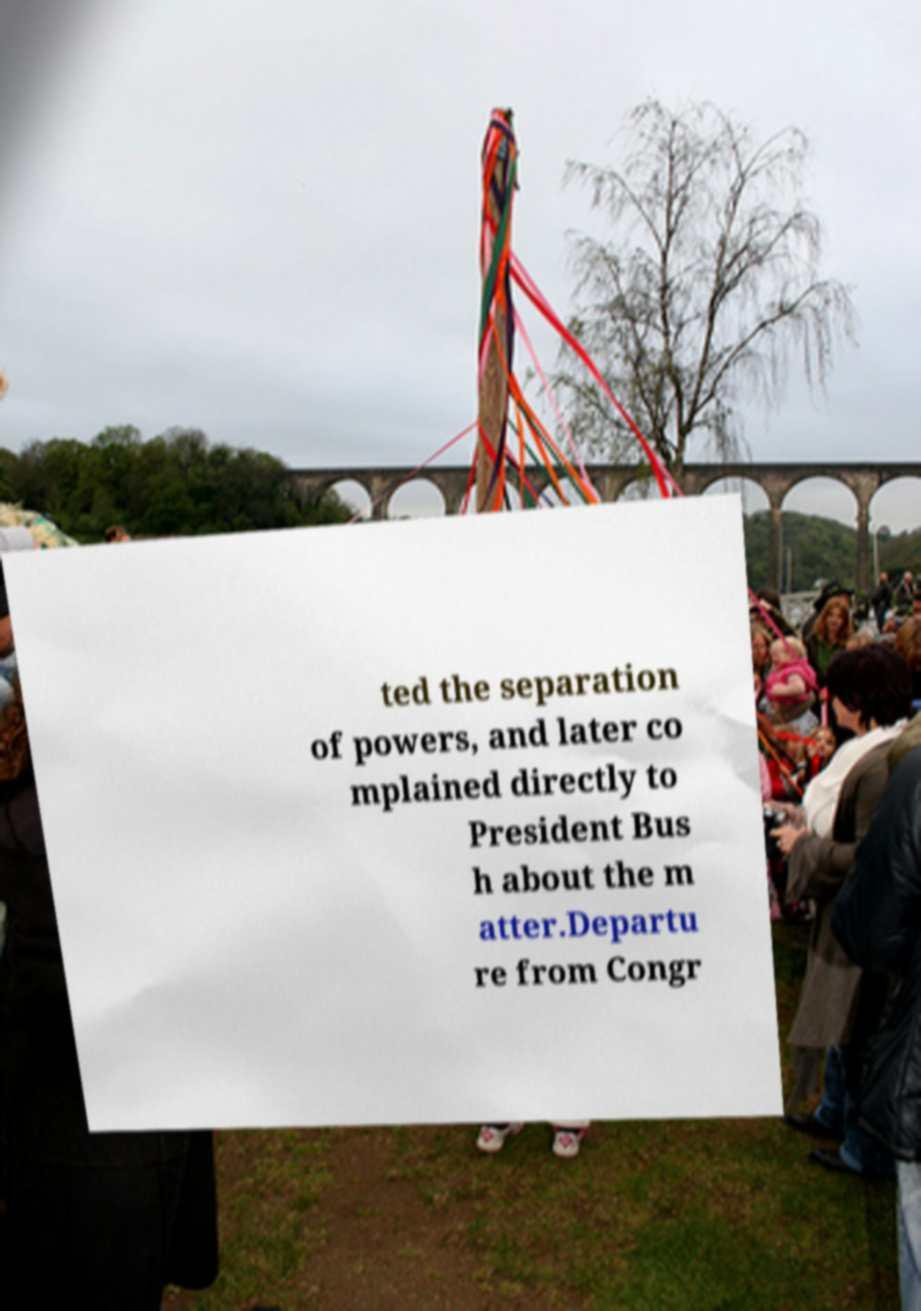Please identify and transcribe the text found in this image. ted the separation of powers, and later co mplained directly to President Bus h about the m atter.Departu re from Congr 